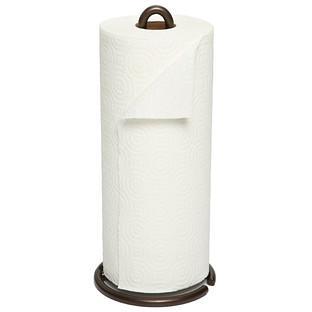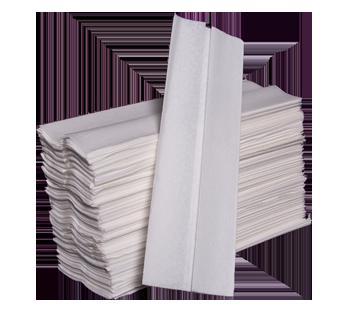The first image is the image on the left, the second image is the image on the right. Analyze the images presented: Is the assertion "At least one image shows an upright roll of white towels on a stand." valid? Answer yes or no. Yes. The first image is the image on the left, the second image is the image on the right. Evaluate the accuracy of this statement regarding the images: "In one image, a stack of folded paper towels is angled so the narrow end of the stack is visible, and one paper towel is displayed partially opened.". Is it true? Answer yes or no. Yes. 